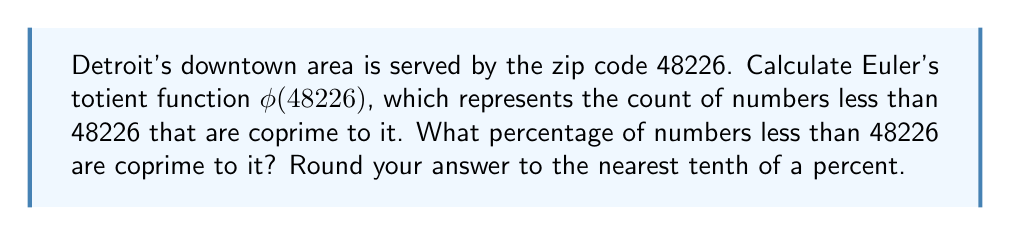Help me with this question. Let's approach this step-by-step:

1) First, we need to find the prime factorization of 48226:
   $48226 = 2 \times 24113$

2) Now, we can apply Euler's totient function. For a prime number $p$, $\phi(p) = p - 1$. For a product of two distinct primes $a$ and $b$, $\phi(ab) = \phi(a) \times \phi(b)$.

3) Therefore:
   $\phi(48226) = \phi(2) \times \phi(24113)$
   $= (2-1) \times (24113-1)$
   $= 1 \times 24112$
   $= 24112$

4) To calculate the percentage, we use:
   $\text{Percentage} = \frac{\phi(48226)}{48226} \times 100\%$

5) Plugging in the values:
   $\frac{24112}{48226} \times 100\% \approx 49.9979\%$

6) Rounding to the nearest tenth of a percent:
   $50.0\%$

This means that exactly half of the numbers less than 48226 are coprime to it, which is a beautiful property of numbers that are the product of two distinct primes!
Answer: 50.0% 